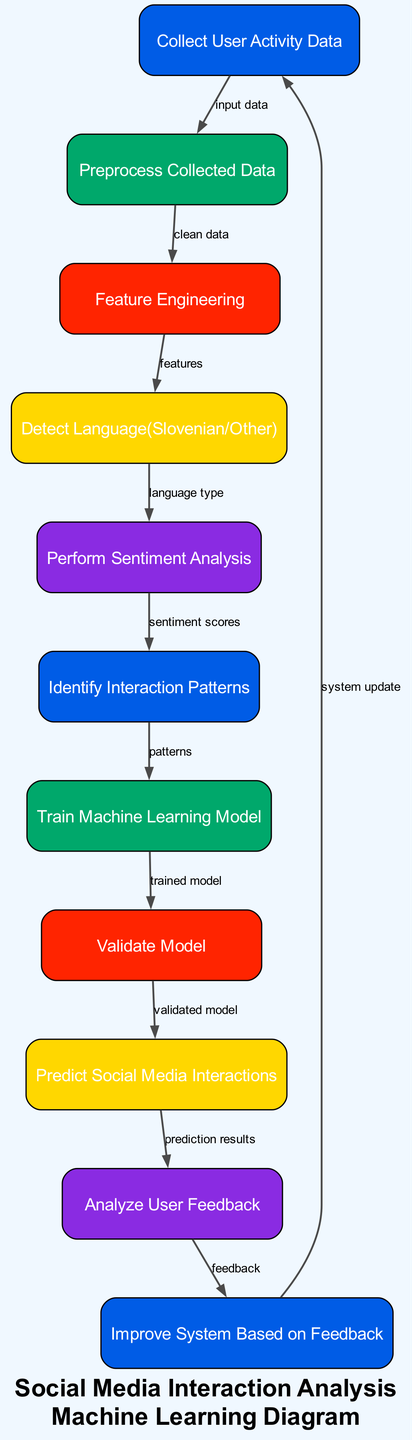What is the first step in this diagram? The first step is represented by the node for collecting user activity data, which indicates that the process begins with gathering data from user interactions.
Answer: Collect User Activity Data How many nodes are present in the diagram? By counting the nodes listed, we see there are 11 individual nodes representing different stages in the analysis process.
Answer: 11 What does the sentiment analysis node output? The sentiment analysis node outputs sentiment scores, which are then used to identify interaction patterns in the following step of the diagram.
Answer: Sentiment Scores Which node comes directly after feature engineering? The node that comes directly after feature engineering is the language detector, which takes the features created in the previous step to identify the language used in social media interactions.
Answer: Detect Language(Slovenian/Other) How is the model validated? The model is validated by the node labeled "Validate Model" which consumes the trained model generated in the training step and ensures its accuracy before moving to prediction.
Answer: Validate Model What is the final step in the diagram? The final step represented in the diagram is "Improve System Based on Feedback," indicating that the system iteratively enhances itself through user feedback received from prior analysis.
Answer: Improve System Based on Feedback Which node receives prediction results as input? The node that receives the prediction results as input is "Analyze User Feedback," which uses these results to understand how users interact with predictions.
Answer: Analyze User Feedback What type of data does the data preprocessing step handle? The data preprocessing step handles the cleaned data that has already been collected and is necessary for further analysis and feature engineering.
Answer: Clean Data What is the relationship between the Interaction Patterns and Training ML Model nodes? The relationship between these nodes reflects that the identified interaction patterns are used to train the machine learning model, making the analysis robust and effective.
Answer: Patterns 